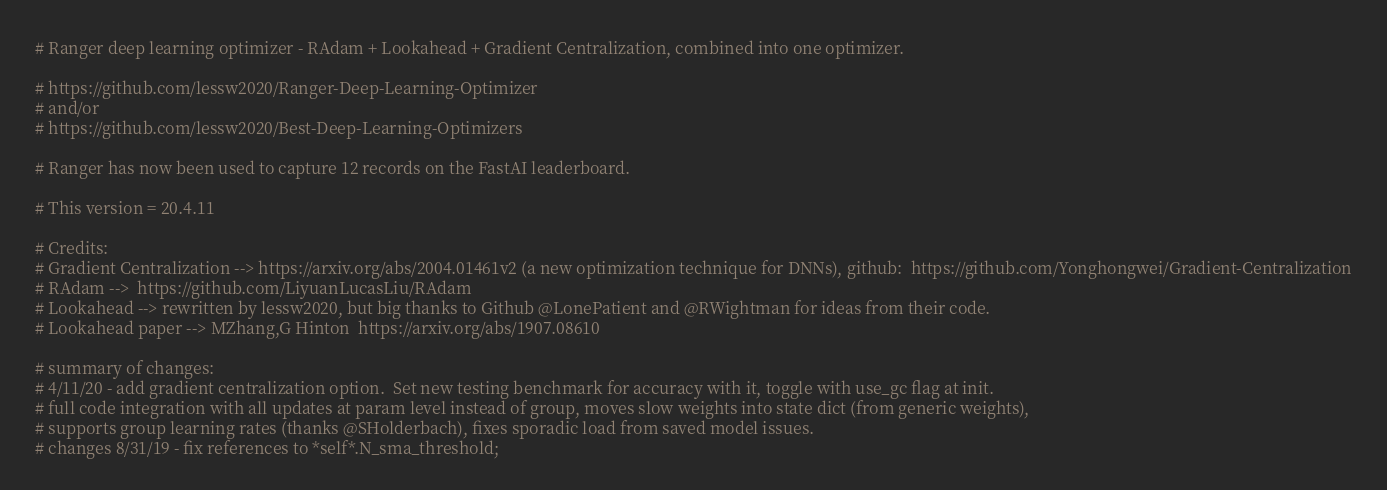<code> <loc_0><loc_0><loc_500><loc_500><_Python_># Ranger deep learning optimizer - RAdam + Lookahead + Gradient Centralization, combined into one optimizer.

# https://github.com/lessw2020/Ranger-Deep-Learning-Optimizer
# and/or
# https://github.com/lessw2020/Best-Deep-Learning-Optimizers

# Ranger has now been used to capture 12 records on the FastAI leaderboard.

# This version = 20.4.11

# Credits:
# Gradient Centralization --> https://arxiv.org/abs/2004.01461v2 (a new optimization technique for DNNs), github:  https://github.com/Yonghongwei/Gradient-Centralization
# RAdam -->  https://github.com/LiyuanLucasLiu/RAdam
# Lookahead --> rewritten by lessw2020, but big thanks to Github @LonePatient and @RWightman for ideas from their code.
# Lookahead paper --> MZhang,G Hinton  https://arxiv.org/abs/1907.08610

# summary of changes:
# 4/11/20 - add gradient centralization option.  Set new testing benchmark for accuracy with it, toggle with use_gc flag at init.
# full code integration with all updates at param level instead of group, moves slow weights into state dict (from generic weights),
# supports group learning rates (thanks @SHolderbach), fixes sporadic load from saved model issues.
# changes 8/31/19 - fix references to *self*.N_sma_threshold;</code> 